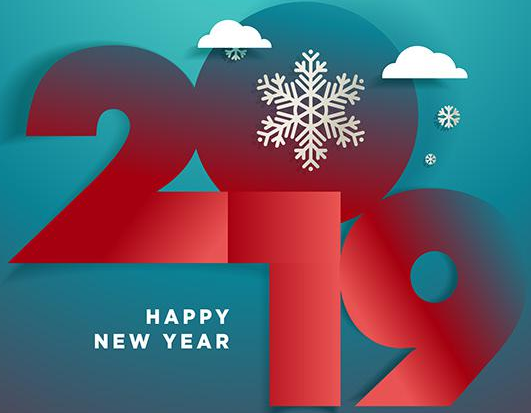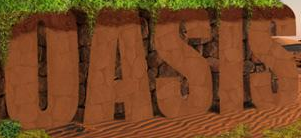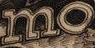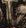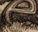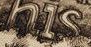What words can you see in these images in sequence, separated by a semicolon? 2019; OASIS; mo; #; e; his 